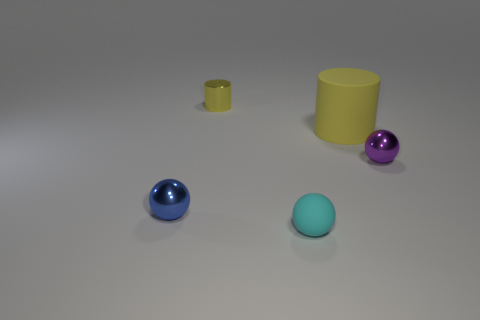Add 1 tiny purple objects. How many objects exist? 6 Subtract all spheres. How many objects are left? 2 Add 4 small yellow things. How many small yellow things are left? 5 Add 4 purple things. How many purple things exist? 5 Subtract 0 green cubes. How many objects are left? 5 Subtract all tiny yellow cylinders. Subtract all gray metallic cubes. How many objects are left? 4 